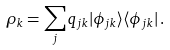Convert formula to latex. <formula><loc_0><loc_0><loc_500><loc_500>\rho _ { k } = \sum _ { j } q _ { j k } | \phi _ { j k } \rangle \langle \phi _ { j k } | \, .</formula> 